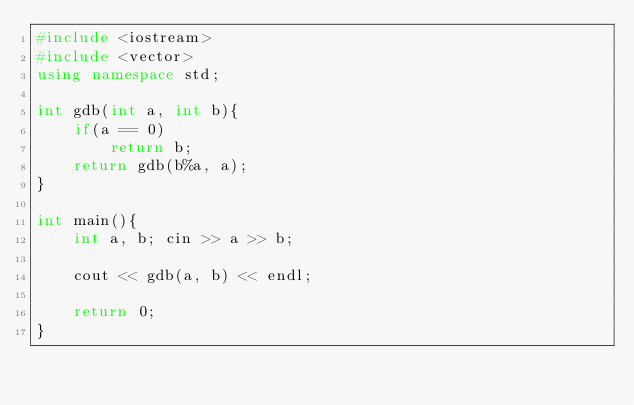Convert code to text. <code><loc_0><loc_0><loc_500><loc_500><_C++_>#include <iostream>
#include <vector>
using namespace std;

int gdb(int a, int b){
    if(a == 0)
        return b;
    return gdb(b%a, a);
}

int main(){
    int a, b; cin >> a >> b;
    
    cout << gdb(a, b) << endl;
    
    return 0;
}

</code> 